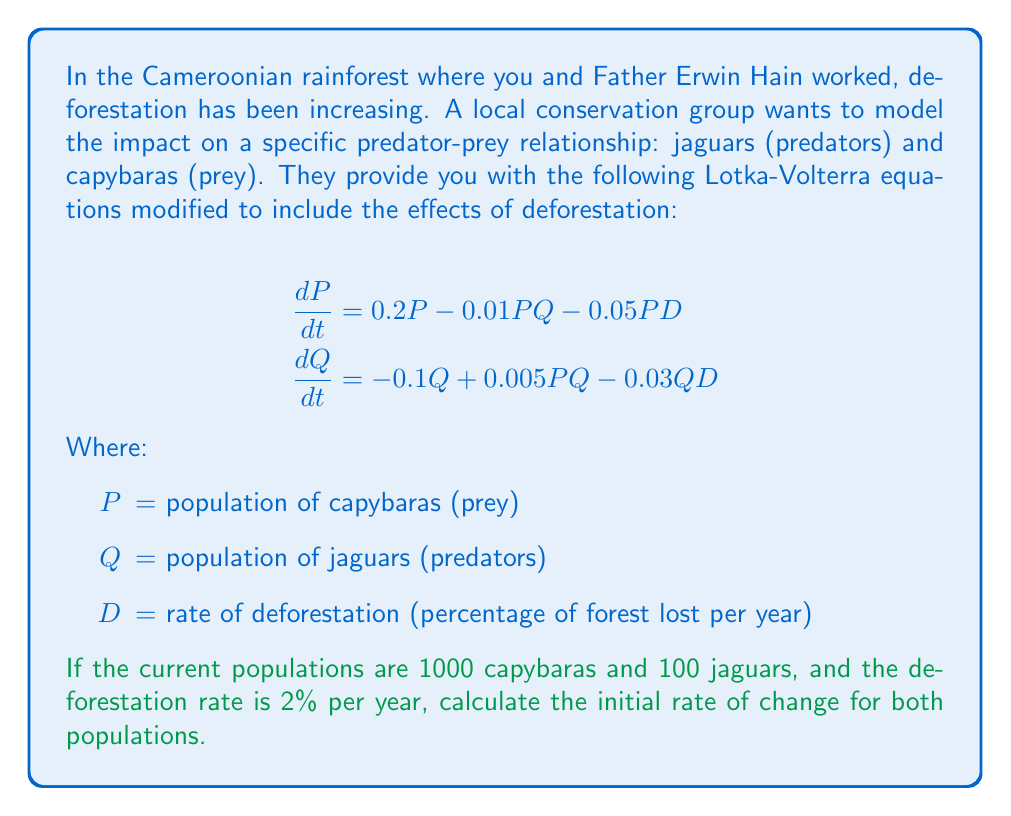Provide a solution to this math problem. To solve this problem, we need to use the given Lotka-Volterra equations and substitute the known values. Let's approach this step-by-step:

1. Given information:
   $P = 1000$ (capybaras)
   $Q = 100$ (jaguars)
   $D = 2$ (2% deforestation rate)

2. For the capybara population (prey):
   $$\frac{dP}{dt} = 0.2P - 0.01PQ - 0.05PD$$
   
   Substituting the values:
   $$\frac{dP}{dt} = 0.2(1000) - 0.01(1000)(100) - 0.05(1000)(2)$$
   $$\frac{dP}{dt} = 200 - 1000 - 100$$
   $$\frac{dP}{dt} = -900$$

3. For the jaguar population (predators):
   $$\frac{dQ}{dt} = -0.1Q + 0.005PQ - 0.03QD$$
   
   Substituting the values:
   $$\frac{dQ}{dt} = -0.1(100) + 0.005(1000)(100) - 0.03(100)(2)$$
   $$\frac{dQ}{dt} = -10 + 500 - 6$$
   $$\frac{dQ}{dt} = 484$$

The negative value for $\frac{dP}{dt}$ indicates that the capybara population is initially decreasing, while the positive value for $\frac{dQ}{dt}$ shows that the jaguar population is initially increasing.
Answer: The initial rate of change for the capybara population is $-900$ individuals per time unit, and for the jaguar population is $484$ individuals per time unit. 